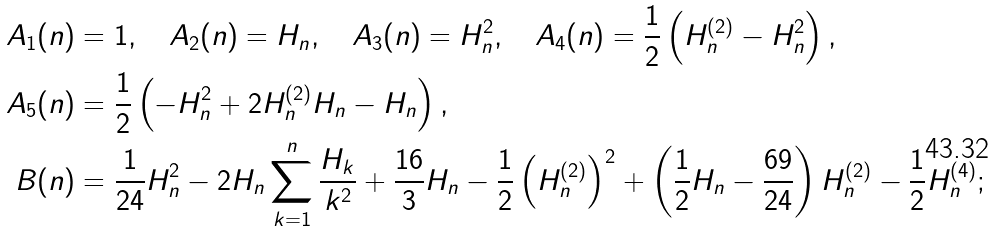<formula> <loc_0><loc_0><loc_500><loc_500>A _ { 1 } ( n ) & = 1 , \quad A _ { 2 } ( n ) = H _ { n } , \quad A _ { 3 } ( n ) = H _ { n } ^ { 2 } , \quad A _ { 4 } ( n ) = \frac { 1 } { 2 } \left ( H _ { n } ^ { ( 2 ) } - H _ { n } ^ { 2 } \right ) , \\ A _ { 5 } ( n ) & = \frac { 1 } { 2 } \left ( - H _ { n } ^ { 2 } + 2 H _ { n } ^ { ( 2 ) } H _ { n } - H _ { n } \right ) , \\ B ( n ) & = \frac { 1 } { 2 4 } H _ { n } ^ { 2 } - 2 H _ { n } \sum _ { k = 1 } ^ { n } \frac { H _ { k } } { k ^ { 2 } } + \frac { 1 6 } { 3 } H _ { n } - \frac { 1 } { 2 } \left ( H _ { n } ^ { ( 2 ) } \right ) ^ { 2 } + \left ( \frac { 1 } { 2 } H _ { n } - \frac { 6 9 } { 2 4 } \right ) H _ { n } ^ { ( 2 ) } - \frac { 1 } { 2 } H _ { n } ^ { ( 4 ) } ;</formula> 